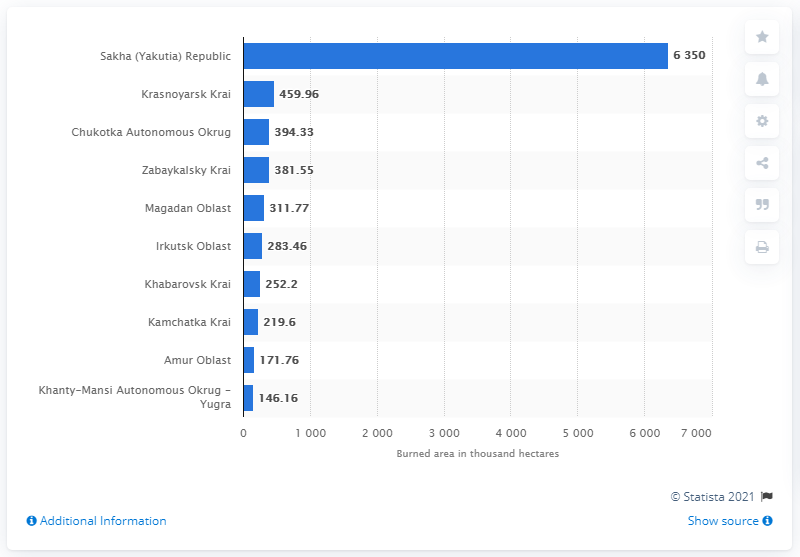Identify some key points in this picture. During the same period, 460 thousand hectares were burned in Krasnoyarsk Krai, a region in Russia. 